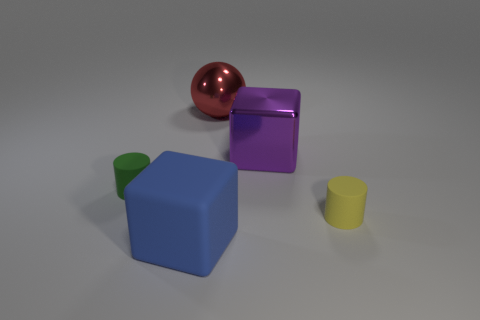Subtract all green cylinders. How many cylinders are left? 1 Add 3 large purple shiny objects. How many objects exist? 8 Subtract all balls. How many objects are left? 4 Subtract 0 blue balls. How many objects are left? 5 Subtract all brown cylinders. Subtract all gray balls. How many cylinders are left? 2 Subtract all large blue objects. Subtract all blue objects. How many objects are left? 3 Add 2 large red metal spheres. How many large red metal spheres are left? 3 Add 5 green cylinders. How many green cylinders exist? 6 